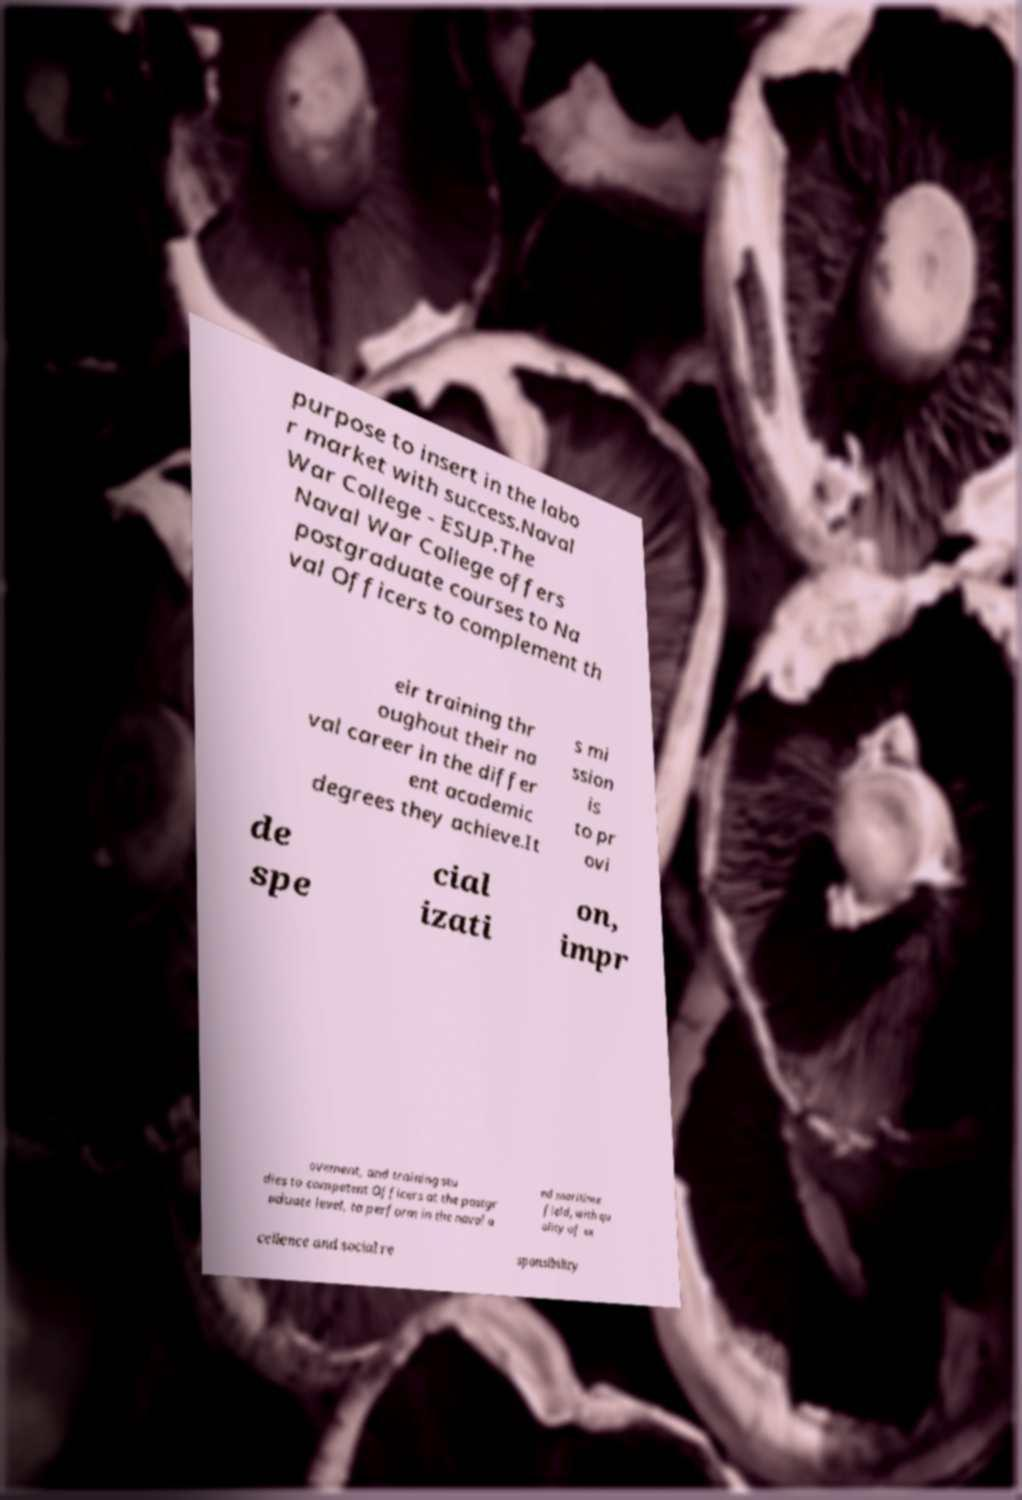Could you extract and type out the text from this image? purpose to insert in the labo r market with success.Naval War College - ESUP.The Naval War College offers postgraduate courses to Na val Officers to complement th eir training thr oughout their na val career in the differ ent academic degrees they achieve.It s mi ssion is to pr ovi de spe cial izati on, impr ovement, and training stu dies to competent Officers at the postgr aduate level, to perform in the naval a nd maritime field, with qu ality of ex cellence and social re sponsibility 